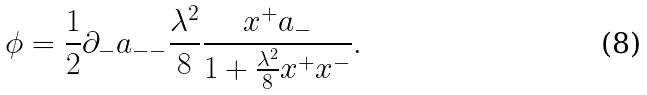<formula> <loc_0><loc_0><loc_500><loc_500>\phi = \frac { 1 } { 2 } \partial _ { - } a _ { - - } \frac { \lambda ^ { 2 } } { 8 } \frac { x ^ { + } a _ { - } } { 1 + \frac { \lambda ^ { 2 } } { 8 } x ^ { + } x ^ { - } } .</formula> 